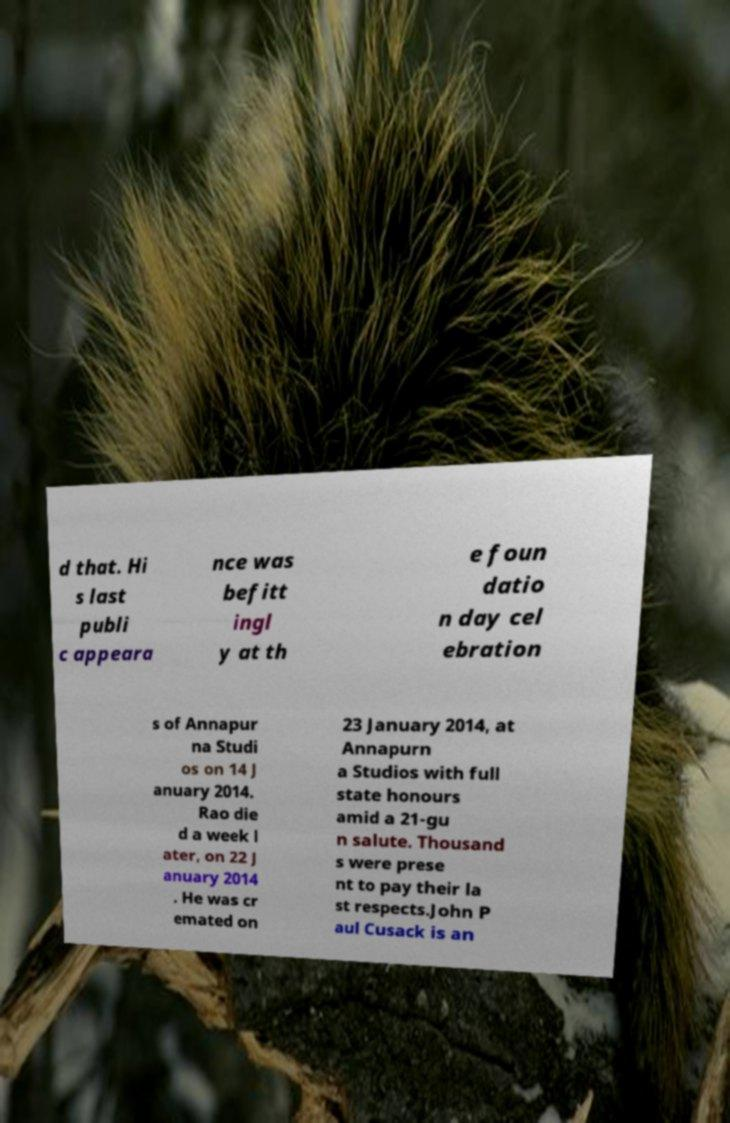Please read and relay the text visible in this image. What does it say? d that. Hi s last publi c appeara nce was befitt ingl y at th e foun datio n day cel ebration s of Annapur na Studi os on 14 J anuary 2014. Rao die d a week l ater, on 22 J anuary 2014 . He was cr emated on 23 January 2014, at Annapurn a Studios with full state honours amid a 21-gu n salute. Thousand s were prese nt to pay their la st respects.John P aul Cusack is an 